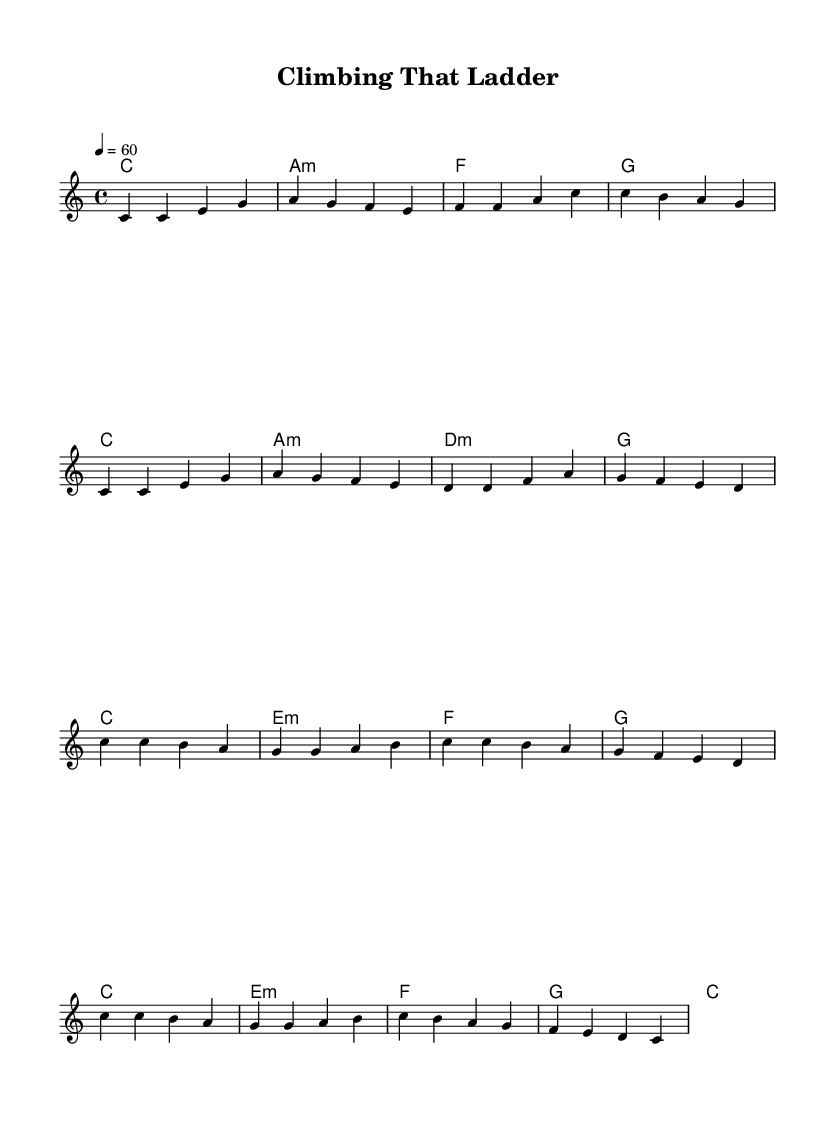What is the key signature of this music? The key signature is indicated at the beginning of the staff, showing no sharps or flats. This corresponds to C major.
Answer: C major What is the time signature of this piece? The time signature is shown at the beginning of the score, represented as 4/4, indicating four beats per measure.
Answer: 4/4 What is the tempo marking for this composition? The tempo marking is indicated in BPM (beats per minute) at the start. The marking shows 60 beats per minute, meaning one beat every second.
Answer: 60 How many measures are in the chorus? To determine the number of measures in the chorus, we can count the measures marked in the chorus section. There are a total of 4 measures in this part of the song.
Answer: 4 What mood does the text in the verse convey? The verse lyrics focus on themes of hard work and perseverance, which typically evoke a resilient and determined mood. This aligns with the general sentiments expressed in soul ballads.
Answer: Resilient What is the function of the chords labeled in the piece? The labeled chords indicate the harmonic structure, providing a foundation for the melody. In this piece, they support the progression from the verse to the chorus, enhancing the emotional delivery of the lyrics.
Answer: Harmonic support 